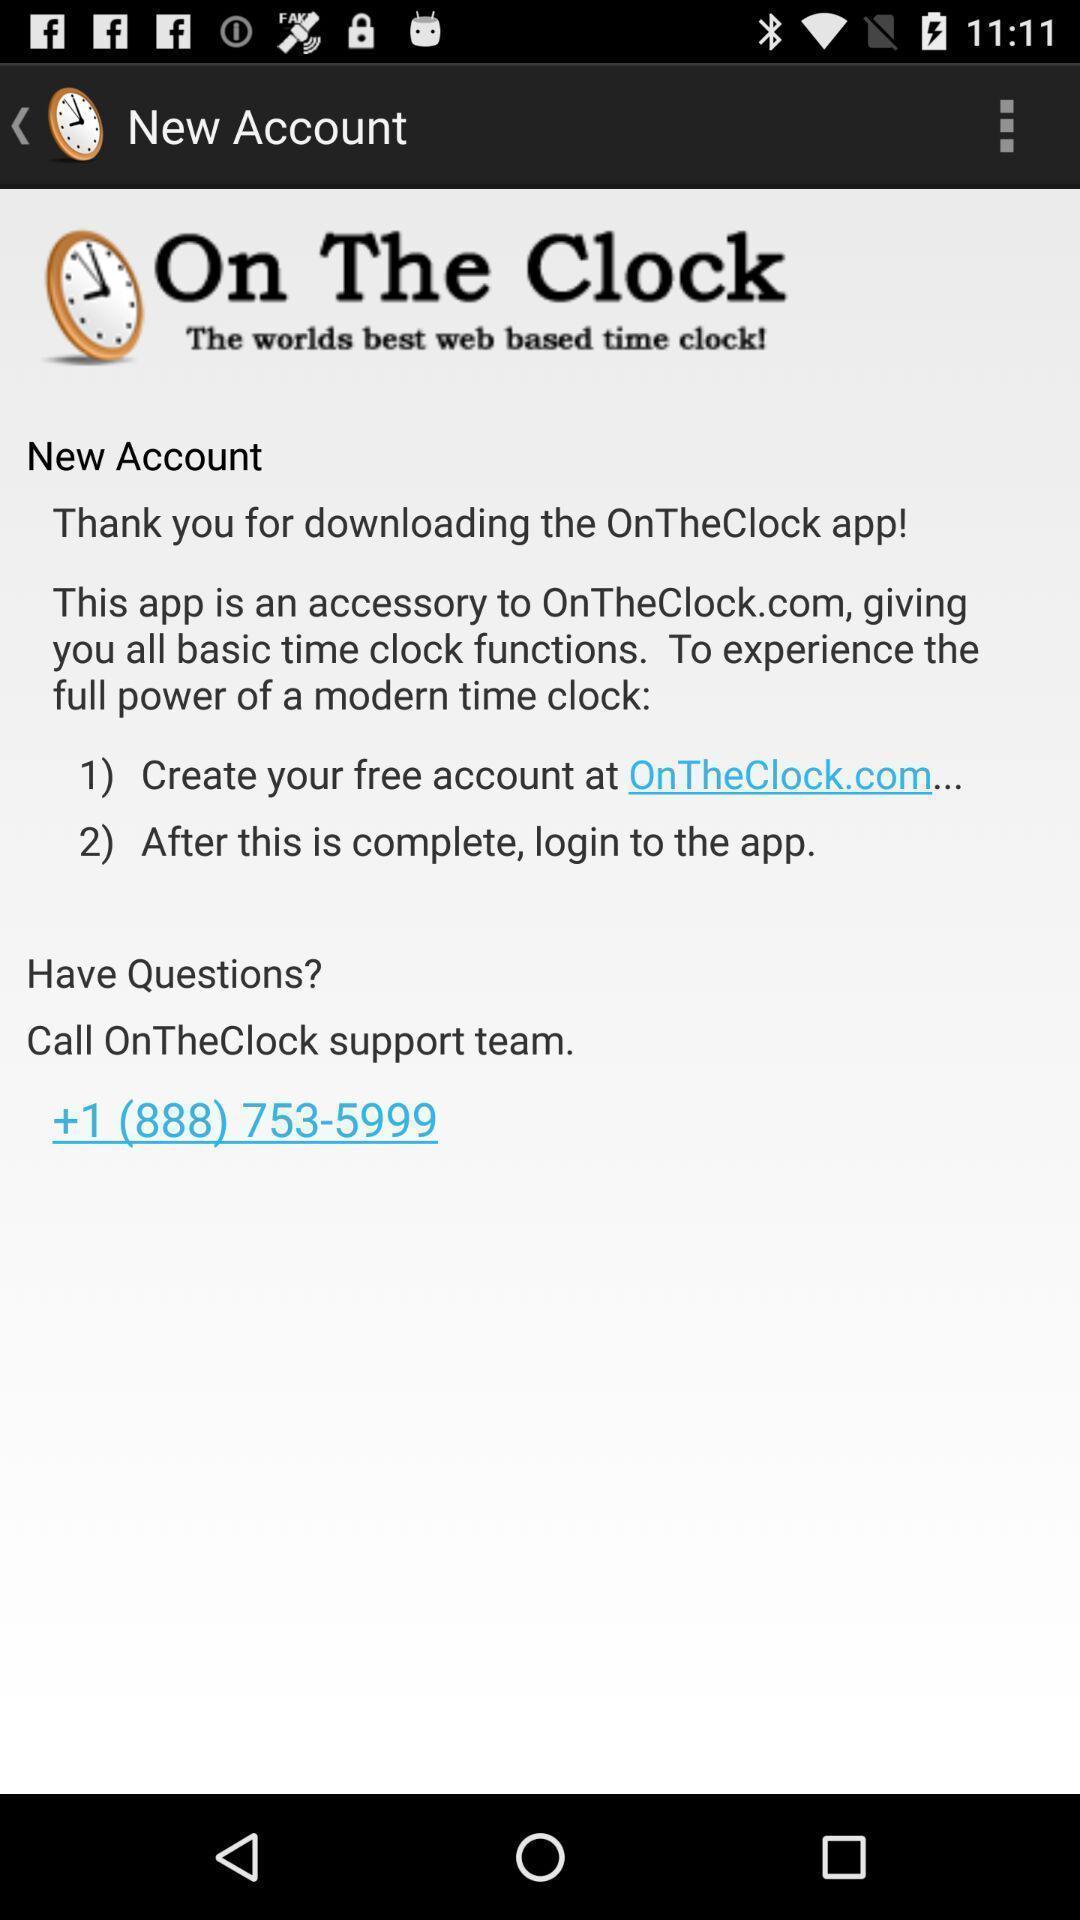Describe the visual elements of this screenshot. Welcome text in the application regarding felicitation. 